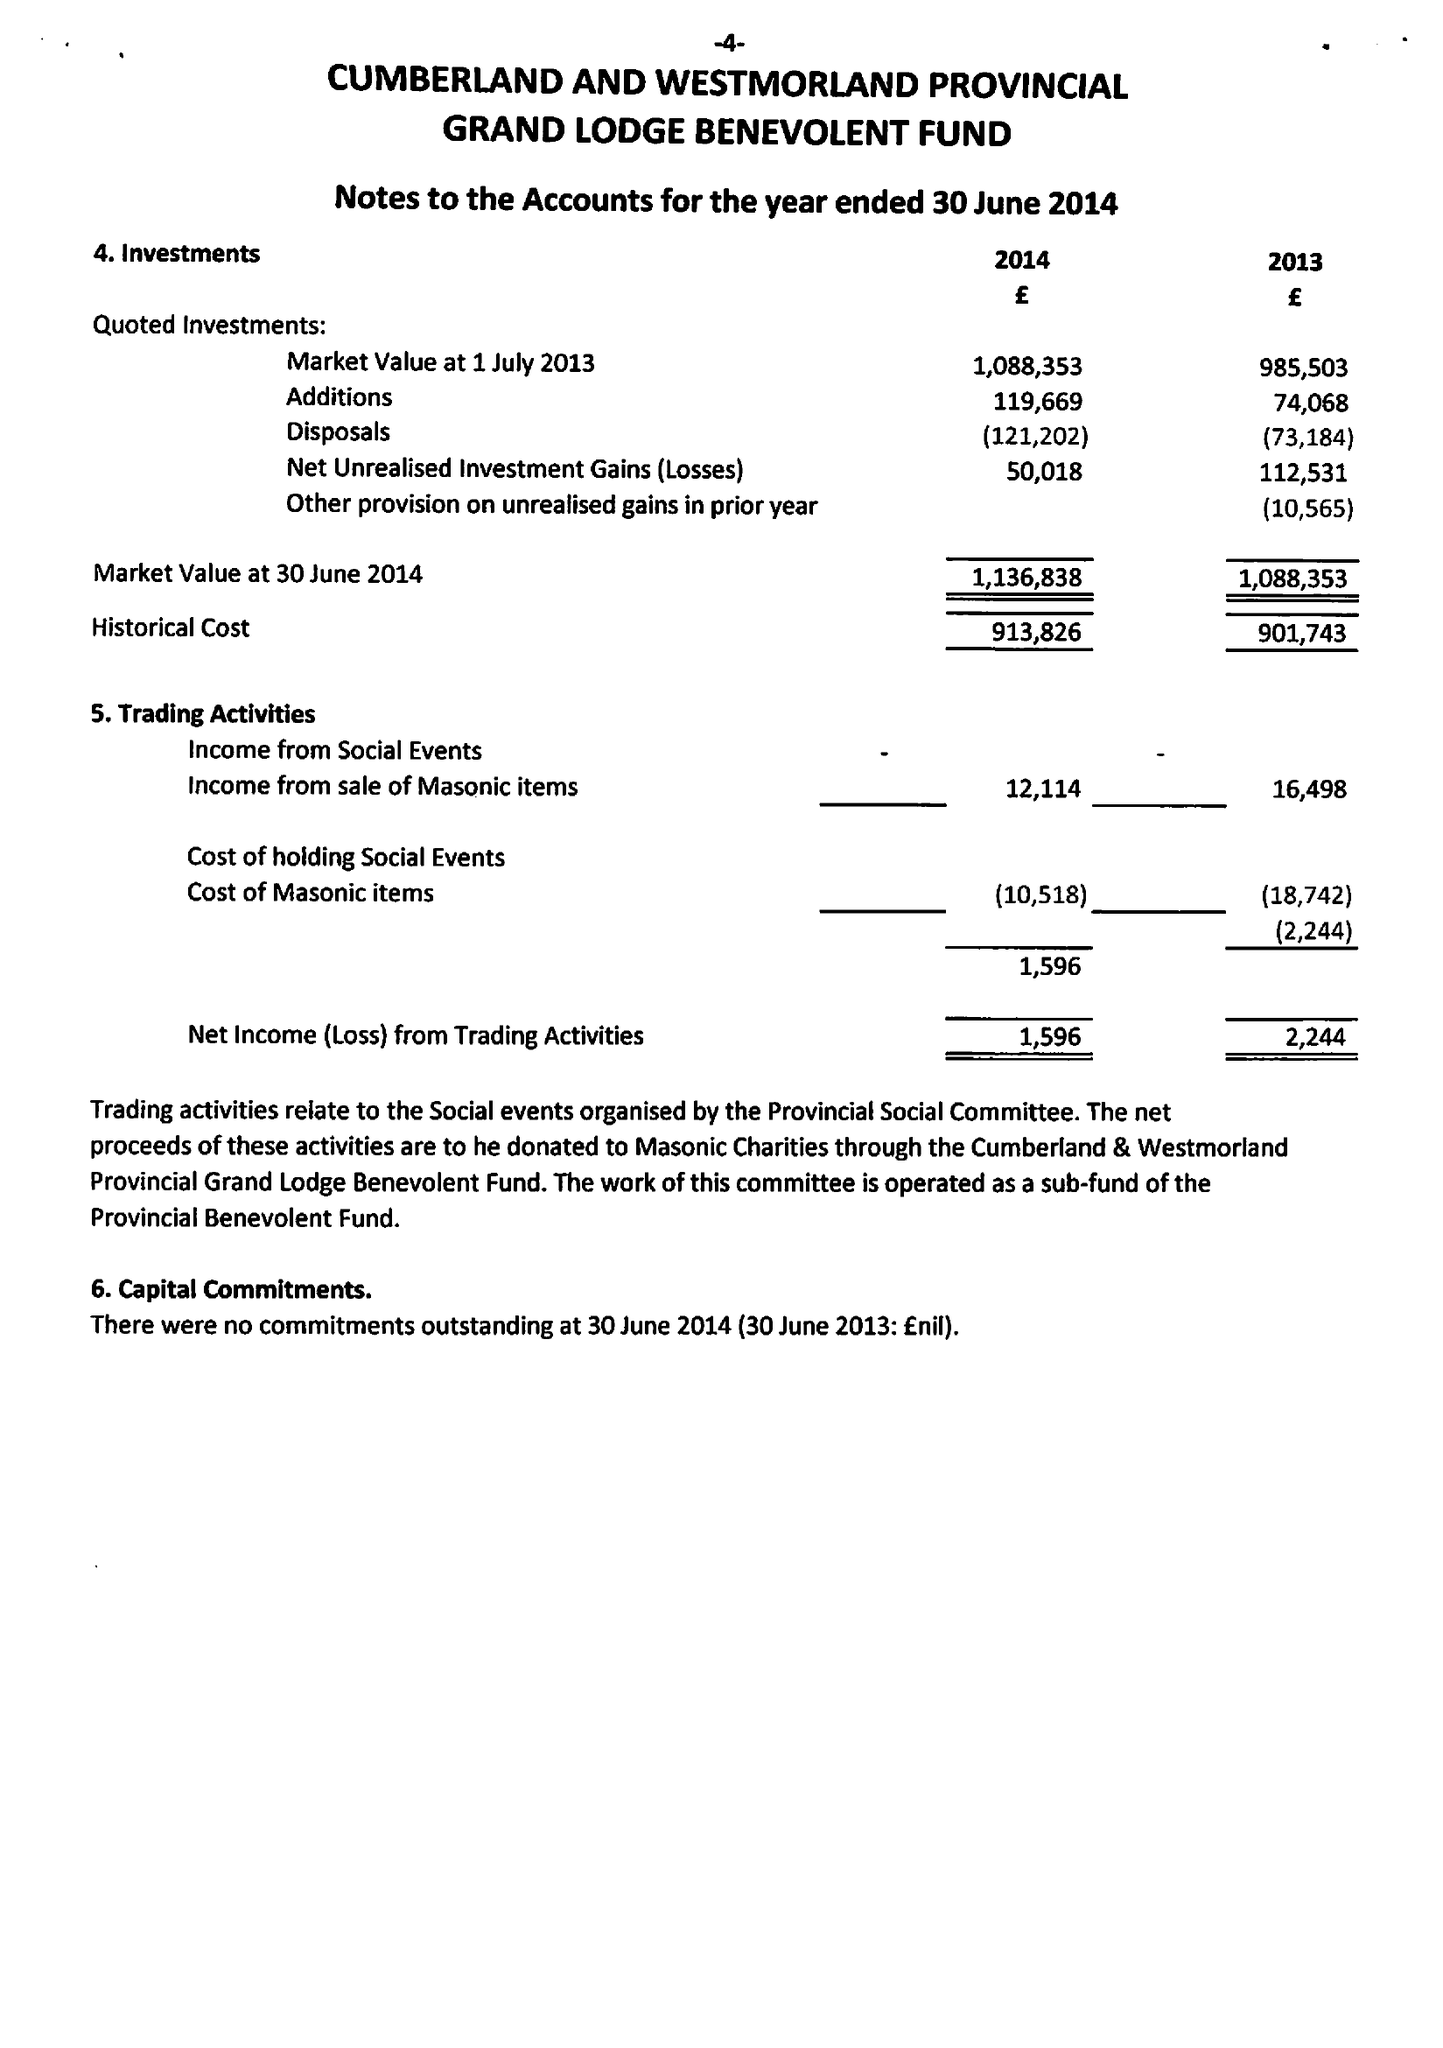What is the value for the address__post_town?
Answer the question using a single word or phrase. CARLISLE 